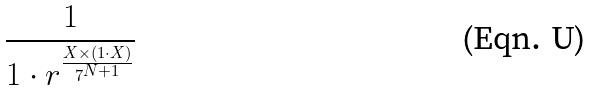Convert formula to latex. <formula><loc_0><loc_0><loc_500><loc_500>\frac { 1 } { 1 \cdot r ^ { \frac { X \times ( 1 \cdot X ) } { 7 ^ { N + 1 } } } }</formula> 